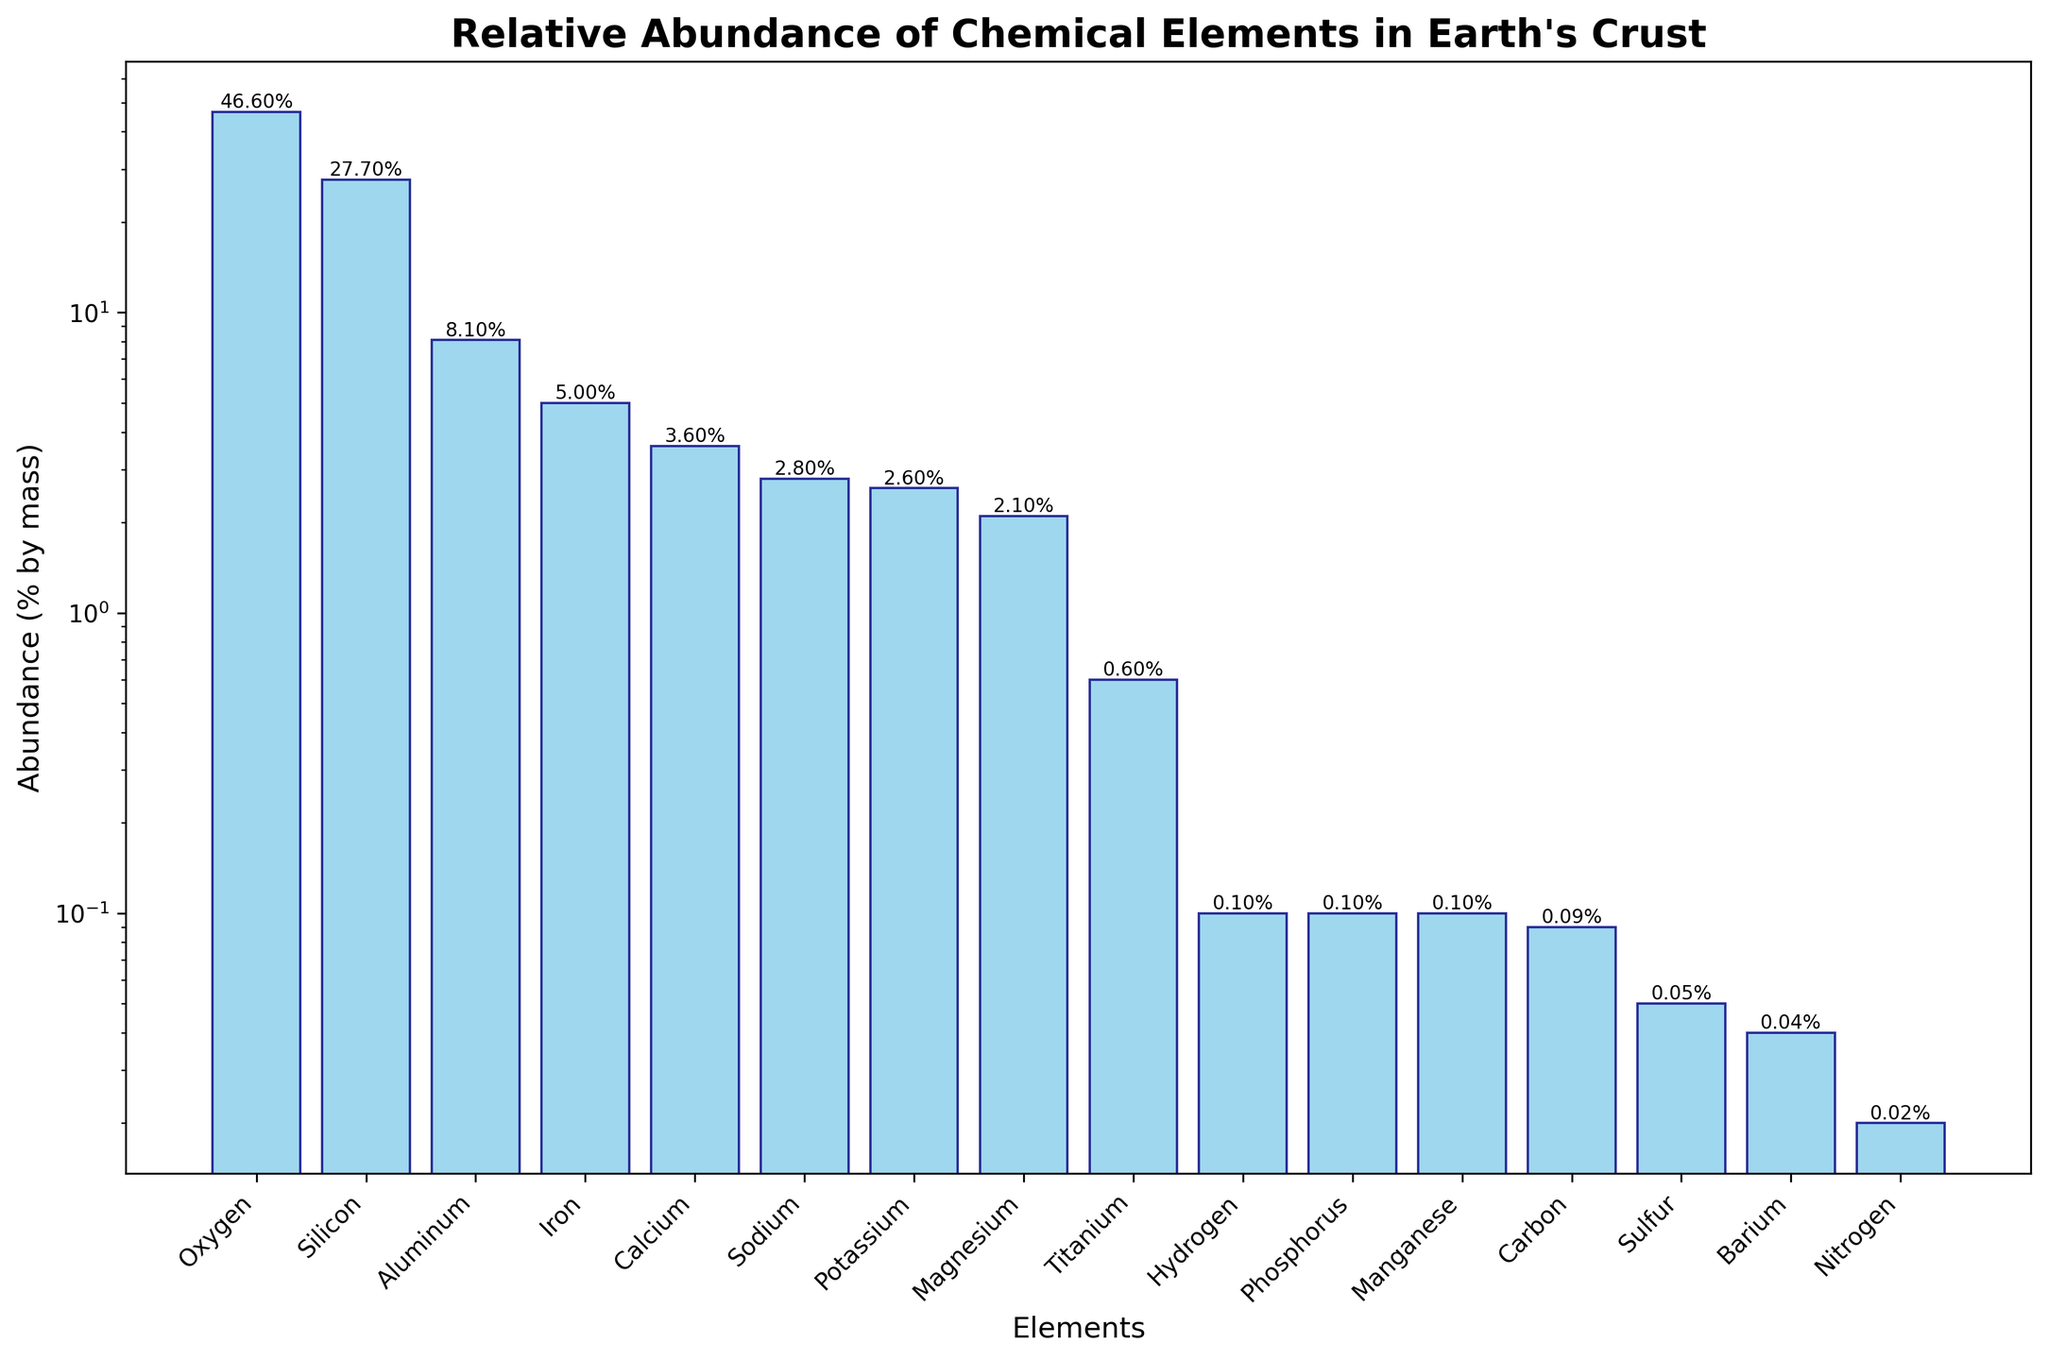What is the most abundant element in the Earth's crust? According to the heights of the bars in the bar chart, Oxygen has the greatest height. This indicates it is the most abundant element in the Earth's crust.
Answer: Oxygen Which element is more abundant, Aluminum or Iron? Referring to the bars for Aluminum and Iron, the height of Aluminum's bar is higher than Iron's, indicating that Aluminum is more abundant.
Answer: Aluminum What's the sum of the abundances of Magnesium and Sodium? From the chart, the abundances are: Magnesium (2.1%) and Sodium (2.8%). Adding these: 2.1 + 2.8 = 4.9.
Answer: 4.9% Which two elements have an equal abundance of 0.1% by mass in the Earth's crust? Looking at the bar heights for elements around 0.1% abundance, Hydrogen, Phosphorus, and Manganese all have 0.1%.
Answer: Hydrogen, Phosphorus, and Manganese Compare the abundances of Hydrogen and Nitrogen. Which is greater and by how much? Hydrogen has an abundance of 0.1%, and Nitrogen has an abundance of 0.02%. The difference is 0.1 - 0.02 = 0.08. Hence, Hydrogen is more abundant by 0.08%.
Answer: Hydrogen, 0.08% Rank the top three most abundant elements in the Earth's crust. By examining the heights of the bars, the three tallest are for Oxygen, Silicon, and Aluminum, in that order.
Answer: Oxygen, Silicon, Aluminum Which element has the least abundance in the Earth's crust, and what is its value? Inspecting the shortest bar, Nitrogen has the least abundance at 0.02%.
Answer: Nitrogen, 0.02% Is Potassium more abundant than Sodium? Comparing the bars of Sodium and Potassium, Sodium's bar is slightly taller at 2.8%, while Potassium's is at 2.6%. Therefore, Sodium is more abundant.
Answer: No, Sodium is more abundant What percentage of the Earth's crust is made up by the four most abundant elements? The four most abundant elements are Oxygen (46.6%), Silicon (27.7%), Aluminum (8.1%), and Iron (5.0%). Summing these, 46.6 + 27.7 + 8.1 + 5.0 = 87.4%.
Answer: 87.4% What is the difference in abundance between Calcium and Titanium? From the chart, Calcium's abundance is 3.6%, and Titanium's is 0.6%. The difference is 3.6 - 0.6 = 3.0%.
Answer: 3.0% 